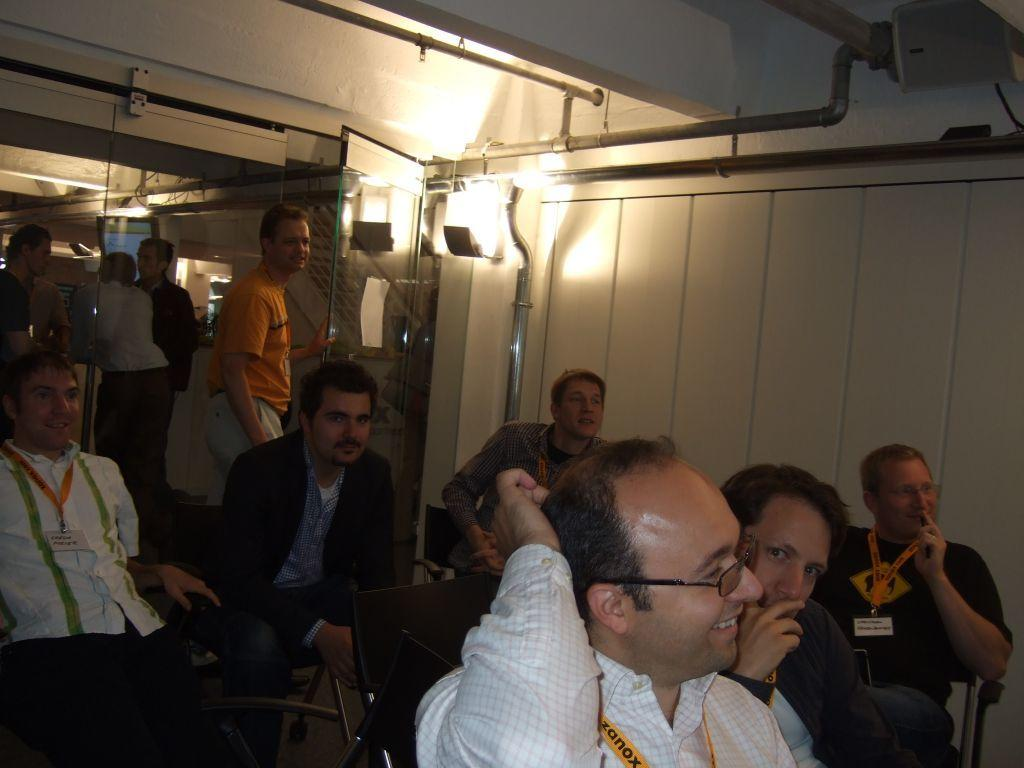How many people are in the image? There is a group of people in the image, but the exact number cannot be determined from the provided facts. What are the people in the image doing? Some people are sitting, some are standing, and some are smiling. What can be seen on the wall in the image? There is a light in the image, which is attached to the wall. What is the purpose of the railing in the image? The railing in the image is likely used for support or safety. What is the screen in the image used for? The purpose of the screen in the image cannot be determined from the provided facts. How many squirrels can be seen climbing the pipes in the image? There are no squirrels present in the image; it features a group of people and various architectural elements. What type of wave is visible in the image? There is no wave present in the image; it is an indoor scene with a group of people and various architectural elements. 